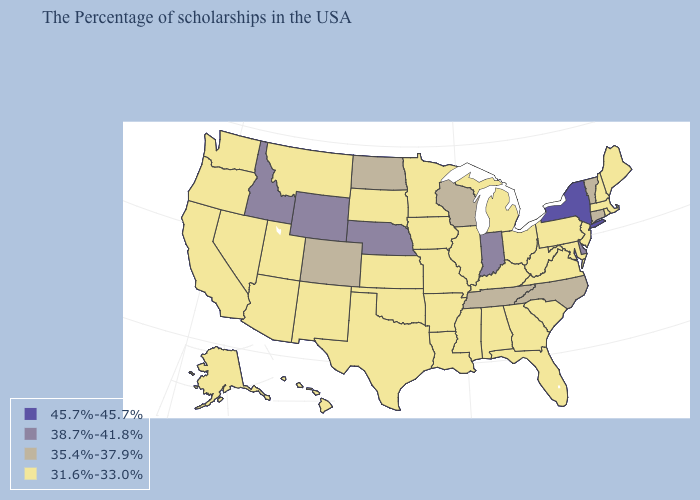What is the lowest value in the South?
Short answer required. 31.6%-33.0%. What is the value of South Dakota?
Keep it brief. 31.6%-33.0%. Which states have the lowest value in the South?
Quick response, please. Maryland, Virginia, South Carolina, West Virginia, Florida, Georgia, Kentucky, Alabama, Mississippi, Louisiana, Arkansas, Oklahoma, Texas. Does Michigan have the same value as Maine?
Answer briefly. Yes. Does the first symbol in the legend represent the smallest category?
Quick response, please. No. Name the states that have a value in the range 35.4%-37.9%?
Be succinct. Vermont, Connecticut, North Carolina, Tennessee, Wisconsin, North Dakota, Colorado. Does Montana have the same value as North Carolina?
Short answer required. No. Does Florida have the same value as Rhode Island?
Short answer required. Yes. What is the value of Arkansas?
Write a very short answer. 31.6%-33.0%. What is the lowest value in states that border Washington?
Keep it brief. 31.6%-33.0%. Does Iowa have the lowest value in the USA?
Concise answer only. Yes. What is the value of Connecticut?
Answer briefly. 35.4%-37.9%. Does the map have missing data?
Quick response, please. No. Does New York have the lowest value in the Northeast?
Keep it brief. No. Name the states that have a value in the range 38.7%-41.8%?
Concise answer only. Delaware, Indiana, Nebraska, Wyoming, Idaho. 